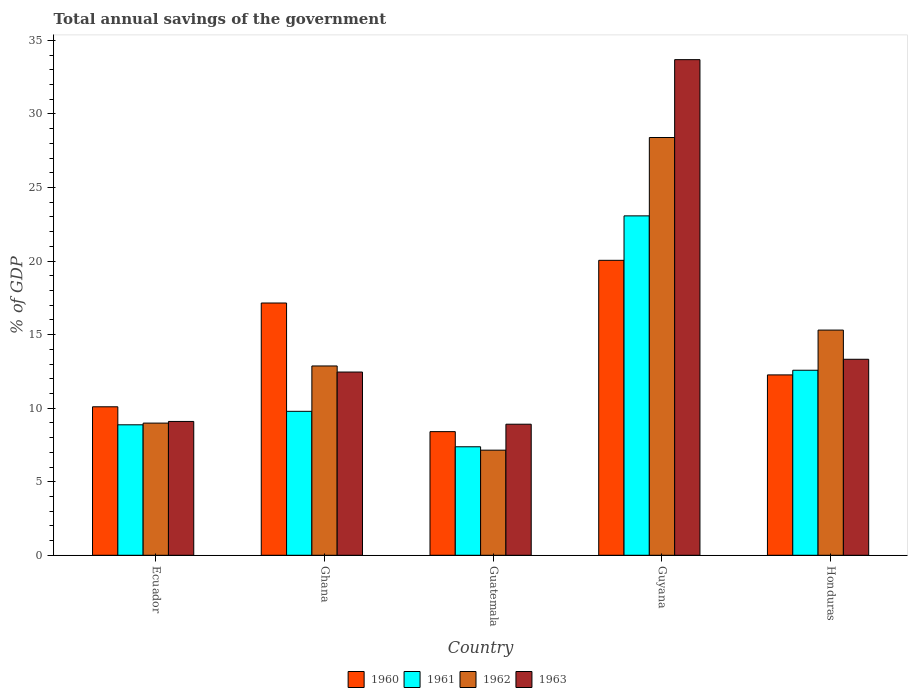How many groups of bars are there?
Provide a succinct answer. 5. Are the number of bars on each tick of the X-axis equal?
Provide a succinct answer. Yes. How many bars are there on the 4th tick from the left?
Provide a short and direct response. 4. How many bars are there on the 5th tick from the right?
Your response must be concise. 4. What is the label of the 1st group of bars from the left?
Give a very brief answer. Ecuador. In how many cases, is the number of bars for a given country not equal to the number of legend labels?
Make the answer very short. 0. What is the total annual savings of the government in 1960 in Honduras?
Offer a very short reply. 12.26. Across all countries, what is the maximum total annual savings of the government in 1961?
Your response must be concise. 23.07. Across all countries, what is the minimum total annual savings of the government in 1960?
Keep it short and to the point. 8.4. In which country was the total annual savings of the government in 1962 maximum?
Your answer should be very brief. Guyana. In which country was the total annual savings of the government in 1961 minimum?
Ensure brevity in your answer.  Guatemala. What is the total total annual savings of the government in 1960 in the graph?
Your answer should be very brief. 67.95. What is the difference between the total annual savings of the government in 1961 in Ghana and that in Honduras?
Provide a short and direct response. -2.79. What is the difference between the total annual savings of the government in 1960 in Ghana and the total annual savings of the government in 1962 in Ecuador?
Provide a short and direct response. 8.16. What is the average total annual savings of the government in 1960 per country?
Provide a succinct answer. 13.59. What is the difference between the total annual savings of the government of/in 1962 and total annual savings of the government of/in 1961 in Guatemala?
Your answer should be very brief. -0.23. In how many countries, is the total annual savings of the government in 1963 greater than 2 %?
Provide a short and direct response. 5. What is the ratio of the total annual savings of the government in 1961 in Ecuador to that in Honduras?
Make the answer very short. 0.71. Is the difference between the total annual savings of the government in 1962 in Ecuador and Honduras greater than the difference between the total annual savings of the government in 1961 in Ecuador and Honduras?
Offer a terse response. No. What is the difference between the highest and the second highest total annual savings of the government in 1961?
Provide a succinct answer. -2.79. What is the difference between the highest and the lowest total annual savings of the government in 1963?
Offer a very short reply. 24.78. How many bars are there?
Give a very brief answer. 20. Are all the bars in the graph horizontal?
Ensure brevity in your answer.  No. How many countries are there in the graph?
Keep it short and to the point. 5. What is the difference between two consecutive major ticks on the Y-axis?
Give a very brief answer. 5. Are the values on the major ticks of Y-axis written in scientific E-notation?
Make the answer very short. No. Does the graph contain any zero values?
Provide a succinct answer. No. Does the graph contain grids?
Keep it short and to the point. No. Where does the legend appear in the graph?
Provide a succinct answer. Bottom center. How many legend labels are there?
Your response must be concise. 4. How are the legend labels stacked?
Give a very brief answer. Horizontal. What is the title of the graph?
Your response must be concise. Total annual savings of the government. Does "1999" appear as one of the legend labels in the graph?
Give a very brief answer. No. What is the label or title of the X-axis?
Offer a very short reply. Country. What is the label or title of the Y-axis?
Make the answer very short. % of GDP. What is the % of GDP of 1960 in Ecuador?
Provide a succinct answer. 10.09. What is the % of GDP in 1961 in Ecuador?
Ensure brevity in your answer.  8.87. What is the % of GDP in 1962 in Ecuador?
Ensure brevity in your answer.  8.98. What is the % of GDP in 1963 in Ecuador?
Offer a terse response. 9.1. What is the % of GDP of 1960 in Ghana?
Your answer should be compact. 17.15. What is the % of GDP in 1961 in Ghana?
Make the answer very short. 9.78. What is the % of GDP in 1962 in Ghana?
Your response must be concise. 12.87. What is the % of GDP of 1963 in Ghana?
Offer a very short reply. 12.45. What is the % of GDP of 1960 in Guatemala?
Your answer should be very brief. 8.4. What is the % of GDP in 1961 in Guatemala?
Offer a very short reply. 7.37. What is the % of GDP in 1962 in Guatemala?
Your answer should be compact. 7.14. What is the % of GDP of 1963 in Guatemala?
Keep it short and to the point. 8.91. What is the % of GDP in 1960 in Guyana?
Provide a short and direct response. 20.05. What is the % of GDP in 1961 in Guyana?
Offer a very short reply. 23.07. What is the % of GDP in 1962 in Guyana?
Provide a short and direct response. 28.4. What is the % of GDP in 1963 in Guyana?
Make the answer very short. 33.69. What is the % of GDP of 1960 in Honduras?
Offer a very short reply. 12.26. What is the % of GDP of 1961 in Honduras?
Your response must be concise. 12.58. What is the % of GDP of 1962 in Honduras?
Your answer should be compact. 15.31. What is the % of GDP in 1963 in Honduras?
Ensure brevity in your answer.  13.32. Across all countries, what is the maximum % of GDP of 1960?
Provide a succinct answer. 20.05. Across all countries, what is the maximum % of GDP in 1961?
Offer a very short reply. 23.07. Across all countries, what is the maximum % of GDP in 1962?
Provide a succinct answer. 28.4. Across all countries, what is the maximum % of GDP of 1963?
Offer a terse response. 33.69. Across all countries, what is the minimum % of GDP of 1960?
Provide a short and direct response. 8.4. Across all countries, what is the minimum % of GDP of 1961?
Provide a succinct answer. 7.37. Across all countries, what is the minimum % of GDP in 1962?
Give a very brief answer. 7.14. Across all countries, what is the minimum % of GDP of 1963?
Keep it short and to the point. 8.91. What is the total % of GDP of 1960 in the graph?
Provide a short and direct response. 67.95. What is the total % of GDP in 1961 in the graph?
Ensure brevity in your answer.  61.67. What is the total % of GDP in 1962 in the graph?
Make the answer very short. 72.7. What is the total % of GDP in 1963 in the graph?
Offer a very short reply. 77.47. What is the difference between the % of GDP of 1960 in Ecuador and that in Ghana?
Provide a short and direct response. -7.05. What is the difference between the % of GDP of 1961 in Ecuador and that in Ghana?
Offer a very short reply. -0.92. What is the difference between the % of GDP in 1962 in Ecuador and that in Ghana?
Your response must be concise. -3.88. What is the difference between the % of GDP of 1963 in Ecuador and that in Ghana?
Provide a short and direct response. -3.36. What is the difference between the % of GDP in 1960 in Ecuador and that in Guatemala?
Keep it short and to the point. 1.69. What is the difference between the % of GDP in 1961 in Ecuador and that in Guatemala?
Make the answer very short. 1.49. What is the difference between the % of GDP in 1962 in Ecuador and that in Guatemala?
Your answer should be compact. 1.84. What is the difference between the % of GDP in 1963 in Ecuador and that in Guatemala?
Your response must be concise. 0.19. What is the difference between the % of GDP in 1960 in Ecuador and that in Guyana?
Offer a terse response. -9.96. What is the difference between the % of GDP of 1961 in Ecuador and that in Guyana?
Give a very brief answer. -14.2. What is the difference between the % of GDP of 1962 in Ecuador and that in Guyana?
Offer a terse response. -19.41. What is the difference between the % of GDP in 1963 in Ecuador and that in Guyana?
Your answer should be compact. -24.59. What is the difference between the % of GDP of 1960 in Ecuador and that in Honduras?
Make the answer very short. -2.17. What is the difference between the % of GDP in 1961 in Ecuador and that in Honduras?
Your answer should be compact. -3.71. What is the difference between the % of GDP of 1962 in Ecuador and that in Honduras?
Your response must be concise. -6.32. What is the difference between the % of GDP of 1963 in Ecuador and that in Honduras?
Provide a succinct answer. -4.23. What is the difference between the % of GDP in 1960 in Ghana and that in Guatemala?
Your answer should be very brief. 8.74. What is the difference between the % of GDP in 1961 in Ghana and that in Guatemala?
Provide a short and direct response. 2.41. What is the difference between the % of GDP in 1962 in Ghana and that in Guatemala?
Give a very brief answer. 5.72. What is the difference between the % of GDP in 1963 in Ghana and that in Guatemala?
Your response must be concise. 3.55. What is the difference between the % of GDP in 1960 in Ghana and that in Guyana?
Offer a terse response. -2.9. What is the difference between the % of GDP of 1961 in Ghana and that in Guyana?
Make the answer very short. -13.28. What is the difference between the % of GDP of 1962 in Ghana and that in Guyana?
Ensure brevity in your answer.  -15.53. What is the difference between the % of GDP in 1963 in Ghana and that in Guyana?
Provide a short and direct response. -21.23. What is the difference between the % of GDP in 1960 in Ghana and that in Honduras?
Give a very brief answer. 4.89. What is the difference between the % of GDP in 1961 in Ghana and that in Honduras?
Provide a short and direct response. -2.79. What is the difference between the % of GDP of 1962 in Ghana and that in Honduras?
Your answer should be compact. -2.44. What is the difference between the % of GDP of 1963 in Ghana and that in Honduras?
Your answer should be compact. -0.87. What is the difference between the % of GDP of 1960 in Guatemala and that in Guyana?
Make the answer very short. -11.64. What is the difference between the % of GDP of 1961 in Guatemala and that in Guyana?
Your response must be concise. -15.7. What is the difference between the % of GDP in 1962 in Guatemala and that in Guyana?
Provide a short and direct response. -21.25. What is the difference between the % of GDP of 1963 in Guatemala and that in Guyana?
Offer a terse response. -24.78. What is the difference between the % of GDP of 1960 in Guatemala and that in Honduras?
Offer a terse response. -3.86. What is the difference between the % of GDP in 1961 in Guatemala and that in Honduras?
Keep it short and to the point. -5.2. What is the difference between the % of GDP in 1962 in Guatemala and that in Honduras?
Provide a succinct answer. -8.16. What is the difference between the % of GDP in 1963 in Guatemala and that in Honduras?
Give a very brief answer. -4.41. What is the difference between the % of GDP of 1960 in Guyana and that in Honduras?
Ensure brevity in your answer.  7.79. What is the difference between the % of GDP of 1961 in Guyana and that in Honduras?
Your answer should be compact. 10.49. What is the difference between the % of GDP of 1962 in Guyana and that in Honduras?
Provide a short and direct response. 13.09. What is the difference between the % of GDP in 1963 in Guyana and that in Honduras?
Offer a terse response. 20.36. What is the difference between the % of GDP in 1960 in Ecuador and the % of GDP in 1961 in Ghana?
Offer a very short reply. 0.31. What is the difference between the % of GDP in 1960 in Ecuador and the % of GDP in 1962 in Ghana?
Keep it short and to the point. -2.77. What is the difference between the % of GDP in 1960 in Ecuador and the % of GDP in 1963 in Ghana?
Your answer should be compact. -2.36. What is the difference between the % of GDP of 1961 in Ecuador and the % of GDP of 1962 in Ghana?
Your answer should be very brief. -4. What is the difference between the % of GDP of 1961 in Ecuador and the % of GDP of 1963 in Ghana?
Make the answer very short. -3.59. What is the difference between the % of GDP of 1962 in Ecuador and the % of GDP of 1963 in Ghana?
Offer a terse response. -3.47. What is the difference between the % of GDP in 1960 in Ecuador and the % of GDP in 1961 in Guatemala?
Offer a very short reply. 2.72. What is the difference between the % of GDP of 1960 in Ecuador and the % of GDP of 1962 in Guatemala?
Offer a terse response. 2.95. What is the difference between the % of GDP in 1960 in Ecuador and the % of GDP in 1963 in Guatemala?
Offer a terse response. 1.18. What is the difference between the % of GDP of 1961 in Ecuador and the % of GDP of 1962 in Guatemala?
Give a very brief answer. 1.72. What is the difference between the % of GDP in 1961 in Ecuador and the % of GDP in 1963 in Guatemala?
Offer a very short reply. -0.04. What is the difference between the % of GDP in 1962 in Ecuador and the % of GDP in 1963 in Guatemala?
Offer a terse response. 0.07. What is the difference between the % of GDP of 1960 in Ecuador and the % of GDP of 1961 in Guyana?
Your response must be concise. -12.98. What is the difference between the % of GDP in 1960 in Ecuador and the % of GDP in 1962 in Guyana?
Keep it short and to the point. -18.3. What is the difference between the % of GDP in 1960 in Ecuador and the % of GDP in 1963 in Guyana?
Provide a short and direct response. -23.59. What is the difference between the % of GDP in 1961 in Ecuador and the % of GDP in 1962 in Guyana?
Offer a very short reply. -19.53. What is the difference between the % of GDP in 1961 in Ecuador and the % of GDP in 1963 in Guyana?
Ensure brevity in your answer.  -24.82. What is the difference between the % of GDP of 1962 in Ecuador and the % of GDP of 1963 in Guyana?
Make the answer very short. -24.7. What is the difference between the % of GDP in 1960 in Ecuador and the % of GDP in 1961 in Honduras?
Provide a short and direct response. -2.48. What is the difference between the % of GDP in 1960 in Ecuador and the % of GDP in 1962 in Honduras?
Offer a terse response. -5.21. What is the difference between the % of GDP in 1960 in Ecuador and the % of GDP in 1963 in Honduras?
Make the answer very short. -3.23. What is the difference between the % of GDP of 1961 in Ecuador and the % of GDP of 1962 in Honduras?
Your response must be concise. -6.44. What is the difference between the % of GDP in 1961 in Ecuador and the % of GDP in 1963 in Honduras?
Give a very brief answer. -4.45. What is the difference between the % of GDP of 1962 in Ecuador and the % of GDP of 1963 in Honduras?
Make the answer very short. -4.34. What is the difference between the % of GDP in 1960 in Ghana and the % of GDP in 1961 in Guatemala?
Provide a succinct answer. 9.77. What is the difference between the % of GDP in 1960 in Ghana and the % of GDP in 1962 in Guatemala?
Your answer should be compact. 10. What is the difference between the % of GDP of 1960 in Ghana and the % of GDP of 1963 in Guatemala?
Your answer should be very brief. 8.24. What is the difference between the % of GDP in 1961 in Ghana and the % of GDP in 1962 in Guatemala?
Your answer should be compact. 2.64. What is the difference between the % of GDP in 1961 in Ghana and the % of GDP in 1963 in Guatemala?
Your response must be concise. 0.88. What is the difference between the % of GDP of 1962 in Ghana and the % of GDP of 1963 in Guatemala?
Ensure brevity in your answer.  3.96. What is the difference between the % of GDP in 1960 in Ghana and the % of GDP in 1961 in Guyana?
Offer a very short reply. -5.92. What is the difference between the % of GDP of 1960 in Ghana and the % of GDP of 1962 in Guyana?
Give a very brief answer. -11.25. What is the difference between the % of GDP of 1960 in Ghana and the % of GDP of 1963 in Guyana?
Your answer should be very brief. -16.54. What is the difference between the % of GDP in 1961 in Ghana and the % of GDP in 1962 in Guyana?
Offer a terse response. -18.61. What is the difference between the % of GDP of 1961 in Ghana and the % of GDP of 1963 in Guyana?
Your response must be concise. -23.9. What is the difference between the % of GDP of 1962 in Ghana and the % of GDP of 1963 in Guyana?
Make the answer very short. -20.82. What is the difference between the % of GDP in 1960 in Ghana and the % of GDP in 1961 in Honduras?
Your answer should be very brief. 4.57. What is the difference between the % of GDP in 1960 in Ghana and the % of GDP in 1962 in Honduras?
Provide a succinct answer. 1.84. What is the difference between the % of GDP in 1960 in Ghana and the % of GDP in 1963 in Honduras?
Provide a succinct answer. 3.82. What is the difference between the % of GDP of 1961 in Ghana and the % of GDP of 1962 in Honduras?
Provide a succinct answer. -5.52. What is the difference between the % of GDP in 1961 in Ghana and the % of GDP in 1963 in Honduras?
Provide a short and direct response. -3.54. What is the difference between the % of GDP of 1962 in Ghana and the % of GDP of 1963 in Honduras?
Your answer should be very brief. -0.46. What is the difference between the % of GDP in 1960 in Guatemala and the % of GDP in 1961 in Guyana?
Your answer should be very brief. -14.67. What is the difference between the % of GDP of 1960 in Guatemala and the % of GDP of 1962 in Guyana?
Your answer should be very brief. -19.99. What is the difference between the % of GDP in 1960 in Guatemala and the % of GDP in 1963 in Guyana?
Give a very brief answer. -25.28. What is the difference between the % of GDP in 1961 in Guatemala and the % of GDP in 1962 in Guyana?
Keep it short and to the point. -21.02. What is the difference between the % of GDP in 1961 in Guatemala and the % of GDP in 1963 in Guyana?
Make the answer very short. -26.31. What is the difference between the % of GDP of 1962 in Guatemala and the % of GDP of 1963 in Guyana?
Your response must be concise. -26.54. What is the difference between the % of GDP in 1960 in Guatemala and the % of GDP in 1961 in Honduras?
Provide a succinct answer. -4.17. What is the difference between the % of GDP of 1960 in Guatemala and the % of GDP of 1962 in Honduras?
Your response must be concise. -6.9. What is the difference between the % of GDP of 1960 in Guatemala and the % of GDP of 1963 in Honduras?
Give a very brief answer. -4.92. What is the difference between the % of GDP of 1961 in Guatemala and the % of GDP of 1962 in Honduras?
Give a very brief answer. -7.93. What is the difference between the % of GDP of 1961 in Guatemala and the % of GDP of 1963 in Honduras?
Provide a short and direct response. -5.95. What is the difference between the % of GDP of 1962 in Guatemala and the % of GDP of 1963 in Honduras?
Ensure brevity in your answer.  -6.18. What is the difference between the % of GDP in 1960 in Guyana and the % of GDP in 1961 in Honduras?
Offer a terse response. 7.47. What is the difference between the % of GDP in 1960 in Guyana and the % of GDP in 1962 in Honduras?
Your answer should be compact. 4.74. What is the difference between the % of GDP in 1960 in Guyana and the % of GDP in 1963 in Honduras?
Make the answer very short. 6.73. What is the difference between the % of GDP of 1961 in Guyana and the % of GDP of 1962 in Honduras?
Ensure brevity in your answer.  7.76. What is the difference between the % of GDP of 1961 in Guyana and the % of GDP of 1963 in Honduras?
Ensure brevity in your answer.  9.75. What is the difference between the % of GDP in 1962 in Guyana and the % of GDP in 1963 in Honduras?
Your answer should be very brief. 15.07. What is the average % of GDP in 1960 per country?
Make the answer very short. 13.59. What is the average % of GDP of 1961 per country?
Give a very brief answer. 12.33. What is the average % of GDP in 1962 per country?
Offer a very short reply. 14.54. What is the average % of GDP of 1963 per country?
Ensure brevity in your answer.  15.49. What is the difference between the % of GDP of 1960 and % of GDP of 1961 in Ecuador?
Keep it short and to the point. 1.22. What is the difference between the % of GDP of 1960 and % of GDP of 1962 in Ecuador?
Make the answer very short. 1.11. What is the difference between the % of GDP of 1960 and % of GDP of 1963 in Ecuador?
Your answer should be compact. 1. What is the difference between the % of GDP of 1961 and % of GDP of 1962 in Ecuador?
Give a very brief answer. -0.12. What is the difference between the % of GDP of 1961 and % of GDP of 1963 in Ecuador?
Your answer should be very brief. -0.23. What is the difference between the % of GDP of 1962 and % of GDP of 1963 in Ecuador?
Ensure brevity in your answer.  -0.11. What is the difference between the % of GDP of 1960 and % of GDP of 1961 in Ghana?
Offer a very short reply. 7.36. What is the difference between the % of GDP in 1960 and % of GDP in 1962 in Ghana?
Make the answer very short. 4.28. What is the difference between the % of GDP in 1960 and % of GDP in 1963 in Ghana?
Offer a terse response. 4.69. What is the difference between the % of GDP in 1961 and % of GDP in 1962 in Ghana?
Ensure brevity in your answer.  -3.08. What is the difference between the % of GDP in 1961 and % of GDP in 1963 in Ghana?
Make the answer very short. -2.67. What is the difference between the % of GDP of 1962 and % of GDP of 1963 in Ghana?
Offer a terse response. 0.41. What is the difference between the % of GDP in 1960 and % of GDP in 1961 in Guatemala?
Ensure brevity in your answer.  1.03. What is the difference between the % of GDP of 1960 and % of GDP of 1962 in Guatemala?
Ensure brevity in your answer.  1.26. What is the difference between the % of GDP of 1960 and % of GDP of 1963 in Guatemala?
Ensure brevity in your answer.  -0.51. What is the difference between the % of GDP of 1961 and % of GDP of 1962 in Guatemala?
Make the answer very short. 0.23. What is the difference between the % of GDP of 1961 and % of GDP of 1963 in Guatemala?
Give a very brief answer. -1.53. What is the difference between the % of GDP of 1962 and % of GDP of 1963 in Guatemala?
Your response must be concise. -1.76. What is the difference between the % of GDP in 1960 and % of GDP in 1961 in Guyana?
Give a very brief answer. -3.02. What is the difference between the % of GDP in 1960 and % of GDP in 1962 in Guyana?
Offer a very short reply. -8.35. What is the difference between the % of GDP of 1960 and % of GDP of 1963 in Guyana?
Your answer should be compact. -13.64. What is the difference between the % of GDP of 1961 and % of GDP of 1962 in Guyana?
Make the answer very short. -5.33. What is the difference between the % of GDP of 1961 and % of GDP of 1963 in Guyana?
Make the answer very short. -10.62. What is the difference between the % of GDP in 1962 and % of GDP in 1963 in Guyana?
Provide a short and direct response. -5.29. What is the difference between the % of GDP of 1960 and % of GDP of 1961 in Honduras?
Make the answer very short. -0.32. What is the difference between the % of GDP in 1960 and % of GDP in 1962 in Honduras?
Your answer should be very brief. -3.05. What is the difference between the % of GDP in 1960 and % of GDP in 1963 in Honduras?
Give a very brief answer. -1.06. What is the difference between the % of GDP in 1961 and % of GDP in 1962 in Honduras?
Your response must be concise. -2.73. What is the difference between the % of GDP of 1961 and % of GDP of 1963 in Honduras?
Your answer should be compact. -0.75. What is the difference between the % of GDP in 1962 and % of GDP in 1963 in Honduras?
Your response must be concise. 1.98. What is the ratio of the % of GDP of 1960 in Ecuador to that in Ghana?
Give a very brief answer. 0.59. What is the ratio of the % of GDP in 1961 in Ecuador to that in Ghana?
Your answer should be very brief. 0.91. What is the ratio of the % of GDP in 1962 in Ecuador to that in Ghana?
Your answer should be very brief. 0.7. What is the ratio of the % of GDP in 1963 in Ecuador to that in Ghana?
Keep it short and to the point. 0.73. What is the ratio of the % of GDP of 1960 in Ecuador to that in Guatemala?
Provide a short and direct response. 1.2. What is the ratio of the % of GDP of 1961 in Ecuador to that in Guatemala?
Give a very brief answer. 1.2. What is the ratio of the % of GDP of 1962 in Ecuador to that in Guatemala?
Offer a terse response. 1.26. What is the ratio of the % of GDP in 1963 in Ecuador to that in Guatemala?
Provide a short and direct response. 1.02. What is the ratio of the % of GDP in 1960 in Ecuador to that in Guyana?
Provide a short and direct response. 0.5. What is the ratio of the % of GDP of 1961 in Ecuador to that in Guyana?
Make the answer very short. 0.38. What is the ratio of the % of GDP in 1962 in Ecuador to that in Guyana?
Ensure brevity in your answer.  0.32. What is the ratio of the % of GDP of 1963 in Ecuador to that in Guyana?
Make the answer very short. 0.27. What is the ratio of the % of GDP of 1960 in Ecuador to that in Honduras?
Give a very brief answer. 0.82. What is the ratio of the % of GDP of 1961 in Ecuador to that in Honduras?
Your answer should be very brief. 0.71. What is the ratio of the % of GDP in 1962 in Ecuador to that in Honduras?
Give a very brief answer. 0.59. What is the ratio of the % of GDP of 1963 in Ecuador to that in Honduras?
Ensure brevity in your answer.  0.68. What is the ratio of the % of GDP of 1960 in Ghana to that in Guatemala?
Ensure brevity in your answer.  2.04. What is the ratio of the % of GDP in 1961 in Ghana to that in Guatemala?
Ensure brevity in your answer.  1.33. What is the ratio of the % of GDP in 1962 in Ghana to that in Guatemala?
Ensure brevity in your answer.  1.8. What is the ratio of the % of GDP of 1963 in Ghana to that in Guatemala?
Your answer should be compact. 1.4. What is the ratio of the % of GDP of 1960 in Ghana to that in Guyana?
Make the answer very short. 0.86. What is the ratio of the % of GDP of 1961 in Ghana to that in Guyana?
Offer a very short reply. 0.42. What is the ratio of the % of GDP of 1962 in Ghana to that in Guyana?
Offer a very short reply. 0.45. What is the ratio of the % of GDP of 1963 in Ghana to that in Guyana?
Your response must be concise. 0.37. What is the ratio of the % of GDP in 1960 in Ghana to that in Honduras?
Offer a terse response. 1.4. What is the ratio of the % of GDP of 1961 in Ghana to that in Honduras?
Give a very brief answer. 0.78. What is the ratio of the % of GDP in 1962 in Ghana to that in Honduras?
Your response must be concise. 0.84. What is the ratio of the % of GDP in 1963 in Ghana to that in Honduras?
Your answer should be compact. 0.93. What is the ratio of the % of GDP of 1960 in Guatemala to that in Guyana?
Make the answer very short. 0.42. What is the ratio of the % of GDP of 1961 in Guatemala to that in Guyana?
Your answer should be very brief. 0.32. What is the ratio of the % of GDP in 1962 in Guatemala to that in Guyana?
Give a very brief answer. 0.25. What is the ratio of the % of GDP in 1963 in Guatemala to that in Guyana?
Offer a terse response. 0.26. What is the ratio of the % of GDP in 1960 in Guatemala to that in Honduras?
Provide a succinct answer. 0.69. What is the ratio of the % of GDP in 1961 in Guatemala to that in Honduras?
Your answer should be compact. 0.59. What is the ratio of the % of GDP of 1962 in Guatemala to that in Honduras?
Provide a short and direct response. 0.47. What is the ratio of the % of GDP of 1963 in Guatemala to that in Honduras?
Offer a terse response. 0.67. What is the ratio of the % of GDP of 1960 in Guyana to that in Honduras?
Give a very brief answer. 1.64. What is the ratio of the % of GDP of 1961 in Guyana to that in Honduras?
Your answer should be compact. 1.83. What is the ratio of the % of GDP of 1962 in Guyana to that in Honduras?
Offer a very short reply. 1.86. What is the ratio of the % of GDP in 1963 in Guyana to that in Honduras?
Offer a very short reply. 2.53. What is the difference between the highest and the second highest % of GDP in 1960?
Make the answer very short. 2.9. What is the difference between the highest and the second highest % of GDP in 1961?
Your answer should be compact. 10.49. What is the difference between the highest and the second highest % of GDP of 1962?
Provide a short and direct response. 13.09. What is the difference between the highest and the second highest % of GDP in 1963?
Your response must be concise. 20.36. What is the difference between the highest and the lowest % of GDP in 1960?
Ensure brevity in your answer.  11.64. What is the difference between the highest and the lowest % of GDP of 1961?
Keep it short and to the point. 15.7. What is the difference between the highest and the lowest % of GDP of 1962?
Ensure brevity in your answer.  21.25. What is the difference between the highest and the lowest % of GDP in 1963?
Keep it short and to the point. 24.78. 